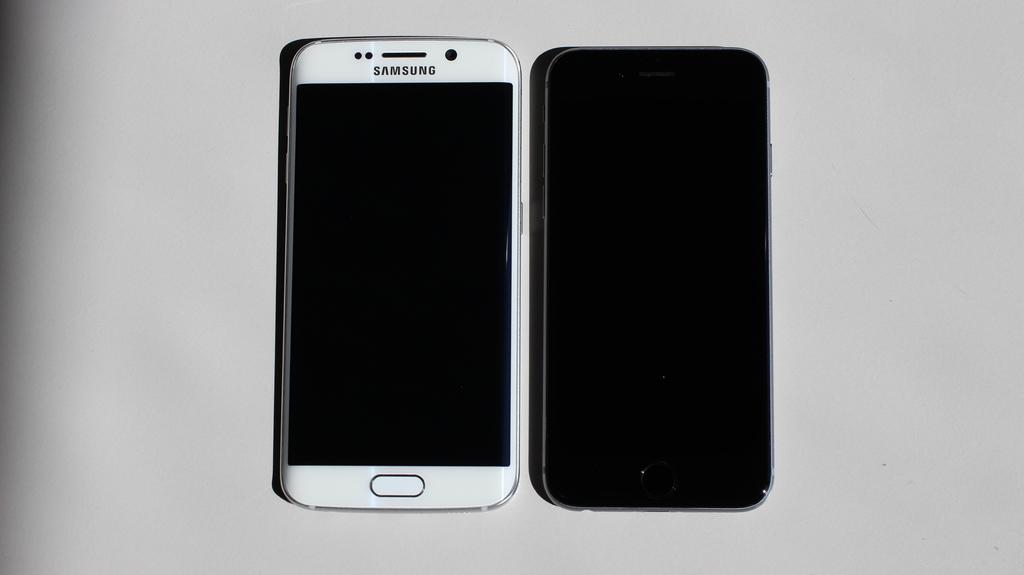<image>
Share a concise interpretation of the image provided. A black iPhone and a white Samsung Galaxy are on a white surface. 